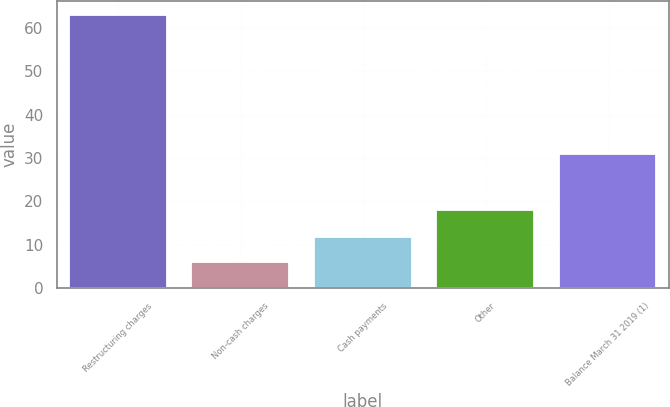Convert chart. <chart><loc_0><loc_0><loc_500><loc_500><bar_chart><fcel>Restructuring charges<fcel>Non-cash charges<fcel>Cash payments<fcel>Other<fcel>Balance March 31 2019 (1)<nl><fcel>63<fcel>6<fcel>11.7<fcel>18<fcel>31<nl></chart> 